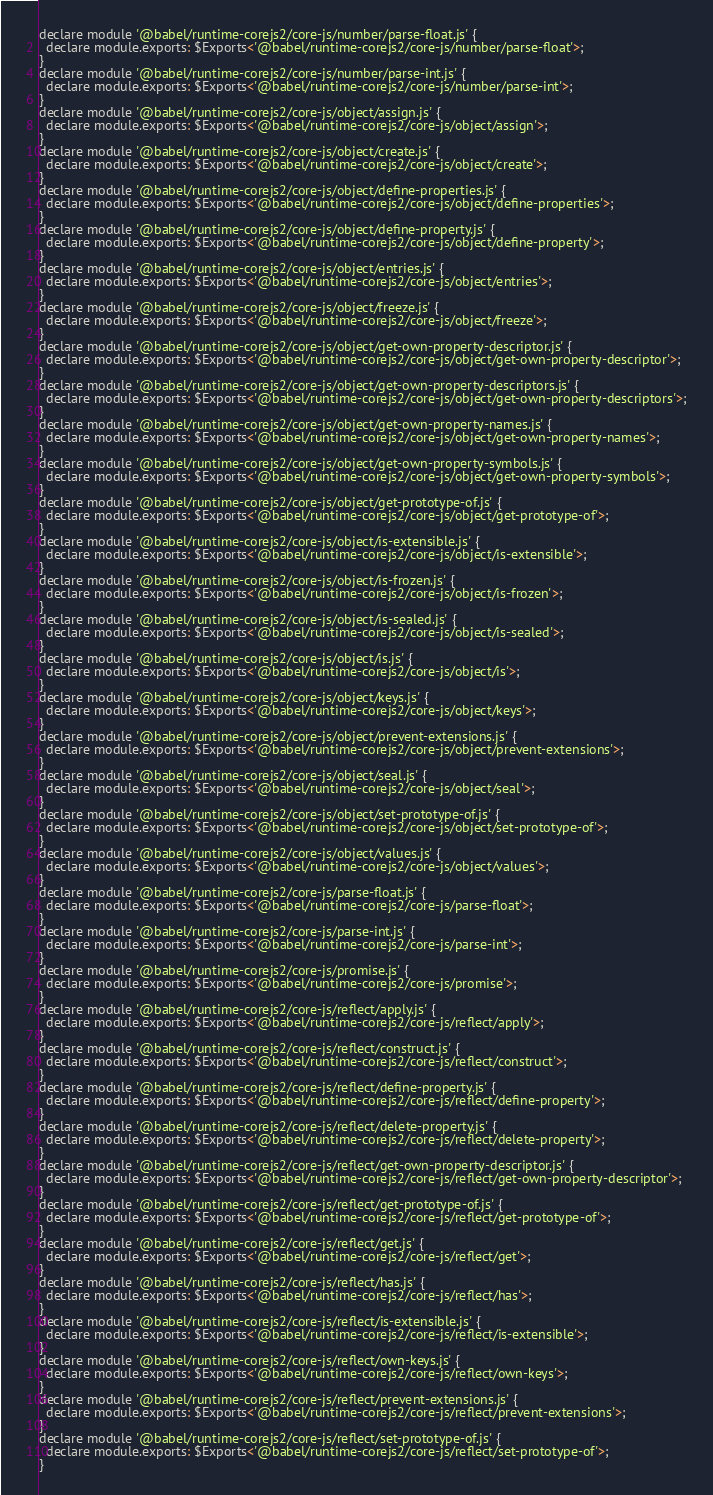Convert code to text. <code><loc_0><loc_0><loc_500><loc_500><_JavaScript_>declare module '@babel/runtime-corejs2/core-js/number/parse-float.js' {
  declare module.exports: $Exports<'@babel/runtime-corejs2/core-js/number/parse-float'>;
}
declare module '@babel/runtime-corejs2/core-js/number/parse-int.js' {
  declare module.exports: $Exports<'@babel/runtime-corejs2/core-js/number/parse-int'>;
}
declare module '@babel/runtime-corejs2/core-js/object/assign.js' {
  declare module.exports: $Exports<'@babel/runtime-corejs2/core-js/object/assign'>;
}
declare module '@babel/runtime-corejs2/core-js/object/create.js' {
  declare module.exports: $Exports<'@babel/runtime-corejs2/core-js/object/create'>;
}
declare module '@babel/runtime-corejs2/core-js/object/define-properties.js' {
  declare module.exports: $Exports<'@babel/runtime-corejs2/core-js/object/define-properties'>;
}
declare module '@babel/runtime-corejs2/core-js/object/define-property.js' {
  declare module.exports: $Exports<'@babel/runtime-corejs2/core-js/object/define-property'>;
}
declare module '@babel/runtime-corejs2/core-js/object/entries.js' {
  declare module.exports: $Exports<'@babel/runtime-corejs2/core-js/object/entries'>;
}
declare module '@babel/runtime-corejs2/core-js/object/freeze.js' {
  declare module.exports: $Exports<'@babel/runtime-corejs2/core-js/object/freeze'>;
}
declare module '@babel/runtime-corejs2/core-js/object/get-own-property-descriptor.js' {
  declare module.exports: $Exports<'@babel/runtime-corejs2/core-js/object/get-own-property-descriptor'>;
}
declare module '@babel/runtime-corejs2/core-js/object/get-own-property-descriptors.js' {
  declare module.exports: $Exports<'@babel/runtime-corejs2/core-js/object/get-own-property-descriptors'>;
}
declare module '@babel/runtime-corejs2/core-js/object/get-own-property-names.js' {
  declare module.exports: $Exports<'@babel/runtime-corejs2/core-js/object/get-own-property-names'>;
}
declare module '@babel/runtime-corejs2/core-js/object/get-own-property-symbols.js' {
  declare module.exports: $Exports<'@babel/runtime-corejs2/core-js/object/get-own-property-symbols'>;
}
declare module '@babel/runtime-corejs2/core-js/object/get-prototype-of.js' {
  declare module.exports: $Exports<'@babel/runtime-corejs2/core-js/object/get-prototype-of'>;
}
declare module '@babel/runtime-corejs2/core-js/object/is-extensible.js' {
  declare module.exports: $Exports<'@babel/runtime-corejs2/core-js/object/is-extensible'>;
}
declare module '@babel/runtime-corejs2/core-js/object/is-frozen.js' {
  declare module.exports: $Exports<'@babel/runtime-corejs2/core-js/object/is-frozen'>;
}
declare module '@babel/runtime-corejs2/core-js/object/is-sealed.js' {
  declare module.exports: $Exports<'@babel/runtime-corejs2/core-js/object/is-sealed'>;
}
declare module '@babel/runtime-corejs2/core-js/object/is.js' {
  declare module.exports: $Exports<'@babel/runtime-corejs2/core-js/object/is'>;
}
declare module '@babel/runtime-corejs2/core-js/object/keys.js' {
  declare module.exports: $Exports<'@babel/runtime-corejs2/core-js/object/keys'>;
}
declare module '@babel/runtime-corejs2/core-js/object/prevent-extensions.js' {
  declare module.exports: $Exports<'@babel/runtime-corejs2/core-js/object/prevent-extensions'>;
}
declare module '@babel/runtime-corejs2/core-js/object/seal.js' {
  declare module.exports: $Exports<'@babel/runtime-corejs2/core-js/object/seal'>;
}
declare module '@babel/runtime-corejs2/core-js/object/set-prototype-of.js' {
  declare module.exports: $Exports<'@babel/runtime-corejs2/core-js/object/set-prototype-of'>;
}
declare module '@babel/runtime-corejs2/core-js/object/values.js' {
  declare module.exports: $Exports<'@babel/runtime-corejs2/core-js/object/values'>;
}
declare module '@babel/runtime-corejs2/core-js/parse-float.js' {
  declare module.exports: $Exports<'@babel/runtime-corejs2/core-js/parse-float'>;
}
declare module '@babel/runtime-corejs2/core-js/parse-int.js' {
  declare module.exports: $Exports<'@babel/runtime-corejs2/core-js/parse-int'>;
}
declare module '@babel/runtime-corejs2/core-js/promise.js' {
  declare module.exports: $Exports<'@babel/runtime-corejs2/core-js/promise'>;
}
declare module '@babel/runtime-corejs2/core-js/reflect/apply.js' {
  declare module.exports: $Exports<'@babel/runtime-corejs2/core-js/reflect/apply'>;
}
declare module '@babel/runtime-corejs2/core-js/reflect/construct.js' {
  declare module.exports: $Exports<'@babel/runtime-corejs2/core-js/reflect/construct'>;
}
declare module '@babel/runtime-corejs2/core-js/reflect/define-property.js' {
  declare module.exports: $Exports<'@babel/runtime-corejs2/core-js/reflect/define-property'>;
}
declare module '@babel/runtime-corejs2/core-js/reflect/delete-property.js' {
  declare module.exports: $Exports<'@babel/runtime-corejs2/core-js/reflect/delete-property'>;
}
declare module '@babel/runtime-corejs2/core-js/reflect/get-own-property-descriptor.js' {
  declare module.exports: $Exports<'@babel/runtime-corejs2/core-js/reflect/get-own-property-descriptor'>;
}
declare module '@babel/runtime-corejs2/core-js/reflect/get-prototype-of.js' {
  declare module.exports: $Exports<'@babel/runtime-corejs2/core-js/reflect/get-prototype-of'>;
}
declare module '@babel/runtime-corejs2/core-js/reflect/get.js' {
  declare module.exports: $Exports<'@babel/runtime-corejs2/core-js/reflect/get'>;
}
declare module '@babel/runtime-corejs2/core-js/reflect/has.js' {
  declare module.exports: $Exports<'@babel/runtime-corejs2/core-js/reflect/has'>;
}
declare module '@babel/runtime-corejs2/core-js/reflect/is-extensible.js' {
  declare module.exports: $Exports<'@babel/runtime-corejs2/core-js/reflect/is-extensible'>;
}
declare module '@babel/runtime-corejs2/core-js/reflect/own-keys.js' {
  declare module.exports: $Exports<'@babel/runtime-corejs2/core-js/reflect/own-keys'>;
}
declare module '@babel/runtime-corejs2/core-js/reflect/prevent-extensions.js' {
  declare module.exports: $Exports<'@babel/runtime-corejs2/core-js/reflect/prevent-extensions'>;
}
declare module '@babel/runtime-corejs2/core-js/reflect/set-prototype-of.js' {
  declare module.exports: $Exports<'@babel/runtime-corejs2/core-js/reflect/set-prototype-of'>;
}</code> 